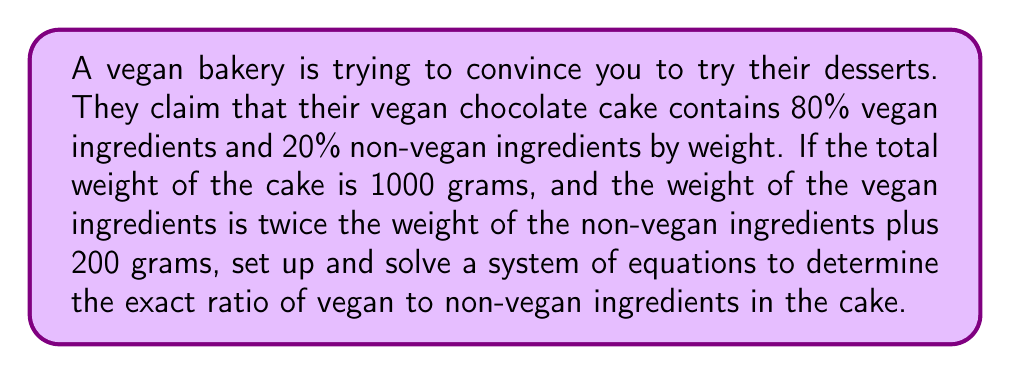Solve this math problem. Let's approach this step-by-step:

1) Let $x$ be the weight of vegan ingredients and $y$ be the weight of non-vegan ingredients.

2) From the total weight of the cake, we can write our first equation:
   $$x + y = 1000$$

3) We're told that the weight of vegan ingredients is twice the weight of non-vegan ingredients plus 200 grams:
   $$x = 2y + 200$$

4) Now we have a system of two equations with two unknowns:
   $$\begin{cases}
   x + y = 1000 \\
   x = 2y + 200
   \end{cases}$$

5) Let's solve this system by substitution. Substitute the second equation into the first:
   $$(2y + 200) + y = 1000$$

6) Simplify:
   $$3y + 200 = 1000$$

7) Subtract 200 from both sides:
   $$3y = 800$$

8) Divide by 3:
   $$y = \frac{800}{3} \approx 266.67$$

9) Now substitute this value of $y$ back into $x = 2y + 200$:
   $$x = 2(266.67) + 200 = 733.33$$

10) To find the ratio, we divide $x$ by $y$:
    $$\frac{x}{y} = \frac{733.33}{266.67} = 2.75$$

Therefore, the exact ratio of vegan to non-vegan ingredients is 2.75 to 1.
Answer: 2.75:1 